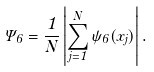Convert formula to latex. <formula><loc_0><loc_0><loc_500><loc_500>\Psi _ { 6 } = \frac { 1 } { N } \left | \sum ^ { N } _ { j = 1 } \psi _ { 6 } ( x _ { j } ) \right | .</formula> 